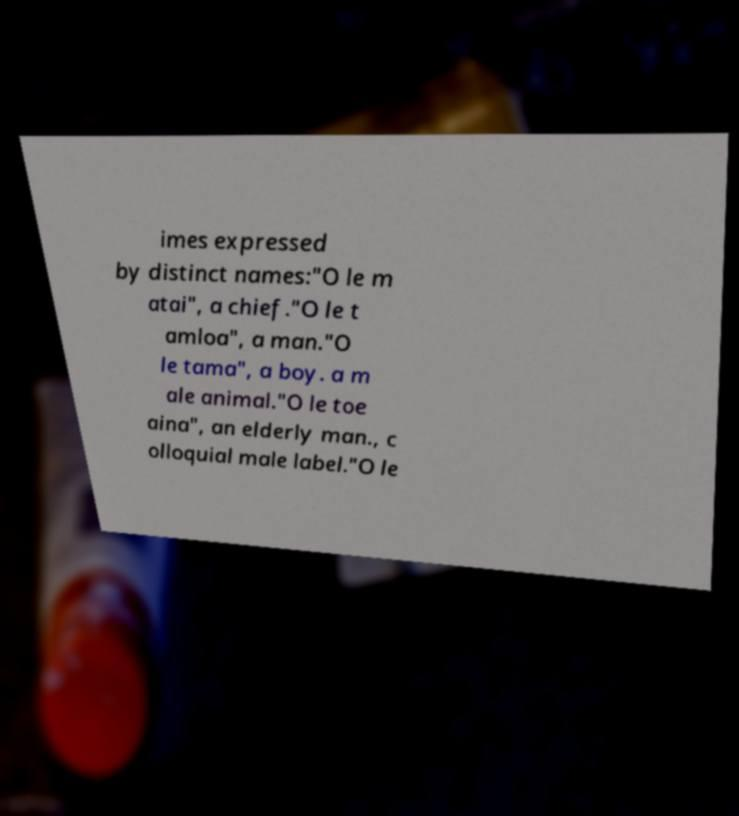For documentation purposes, I need the text within this image transcribed. Could you provide that? imes expressed by distinct names:"O le m atai", a chief."O le t amloa", a man."O le tama", a boy. a m ale animal."O le toe aina", an elderly man., c olloquial male label."O le 